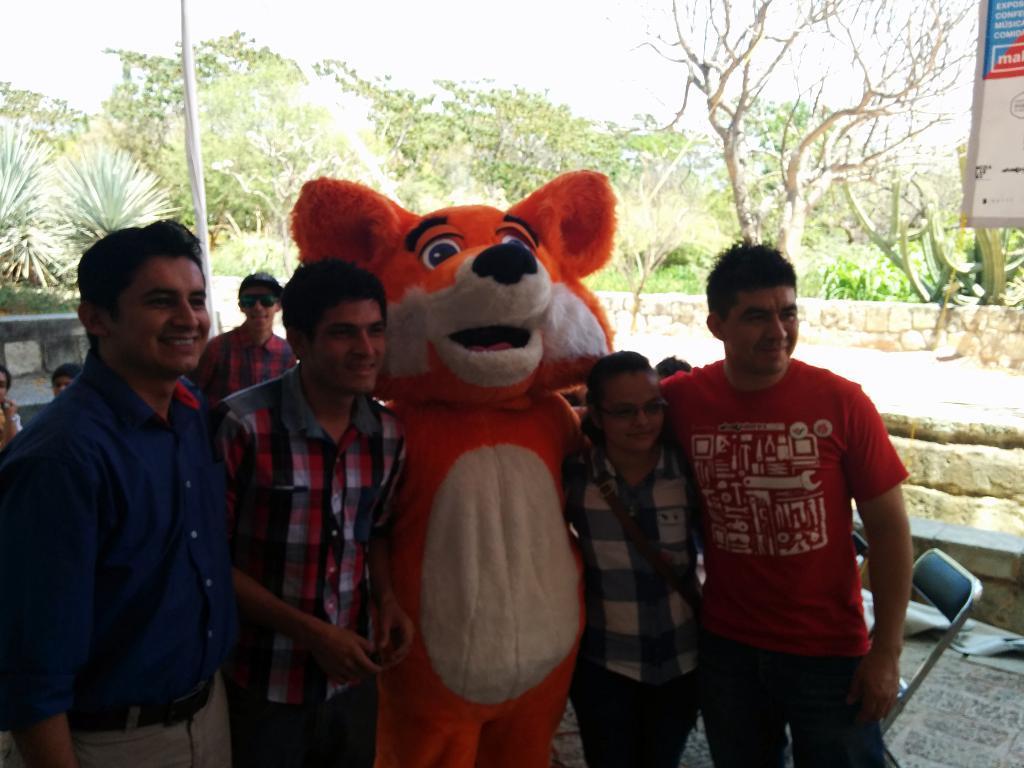In one or two sentences, can you explain what this image depicts? In the center of the image we can see a few people are standing and they are smiling. Among them, we can see one person is wearing a Mickey mouse costume, which is in cream and orange color. In the background, we can see the sky, clouds, trees, chairs, one banner, one pole, grass, few people are sitting, one person is standing and a few other objects. 